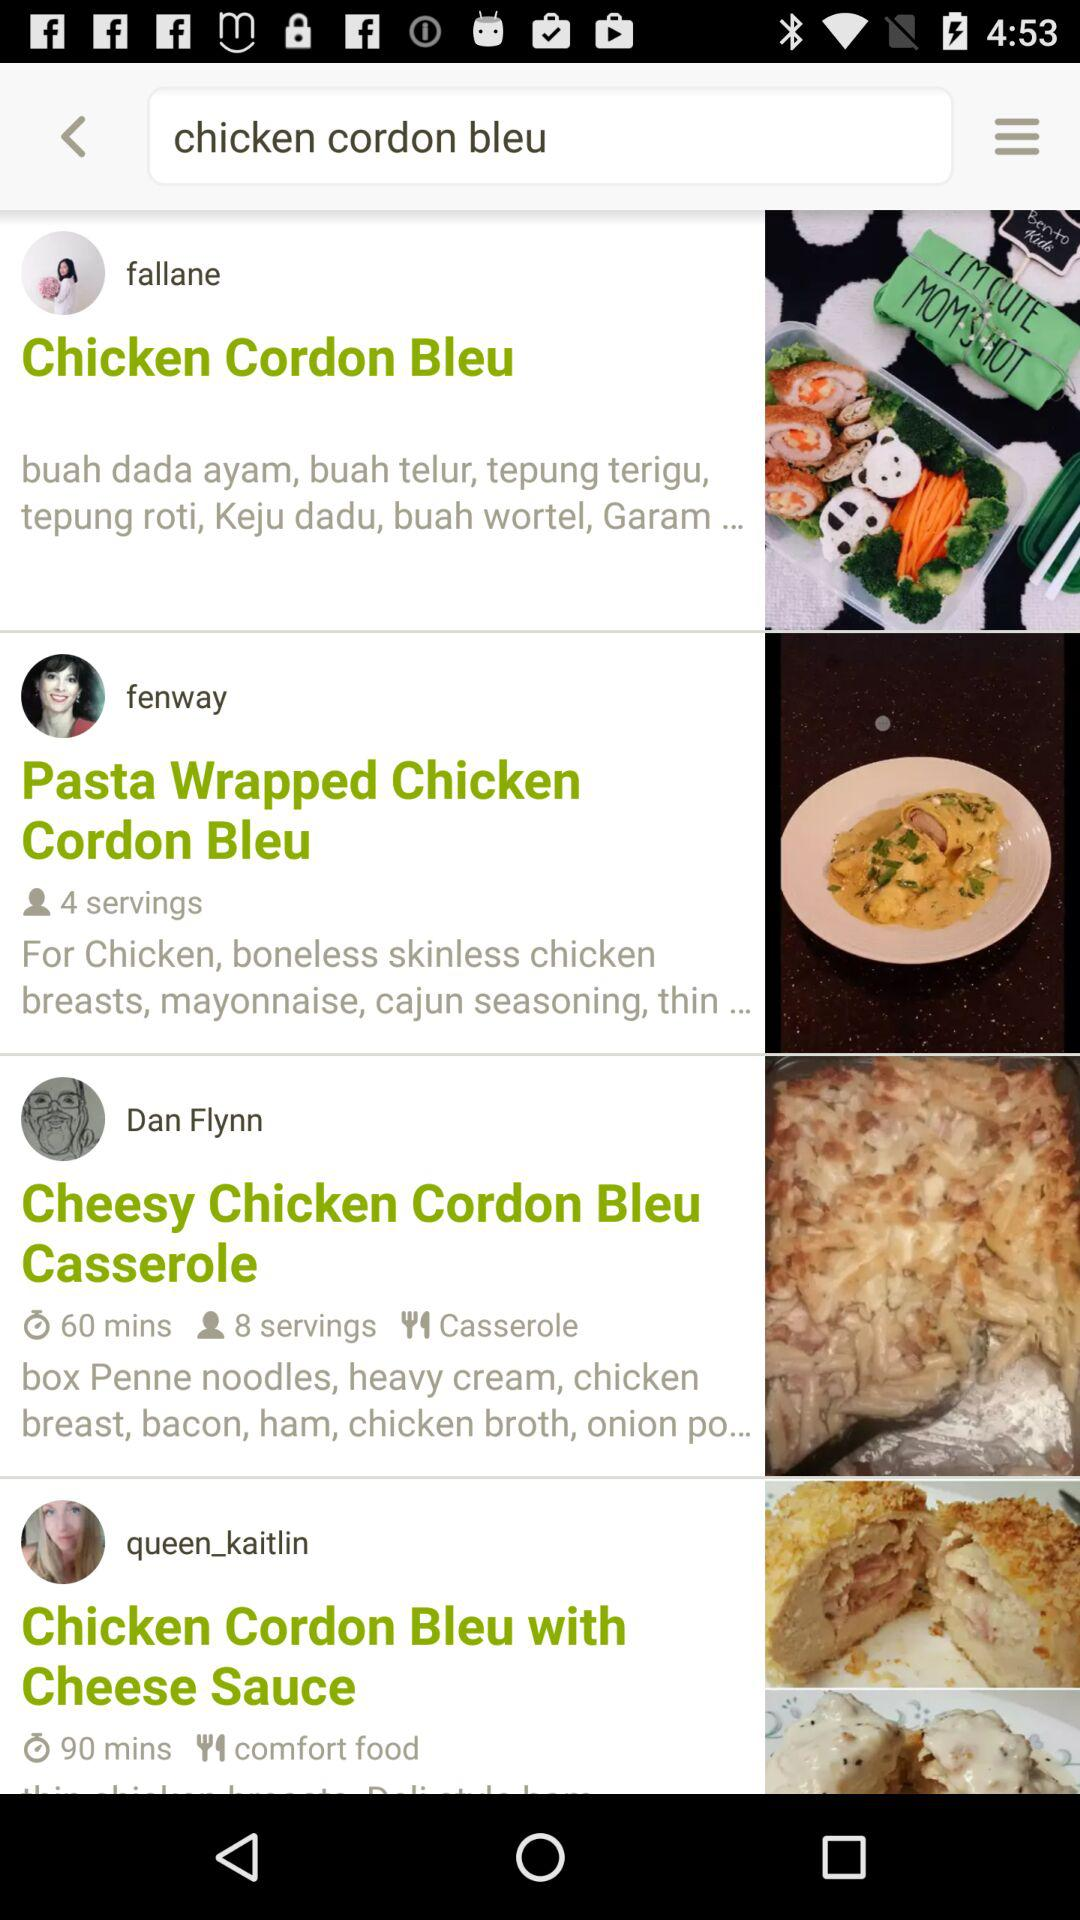How many more minutes does the recipe with the most time require than the recipe with the least time?
Answer the question using a single word or phrase. 30 